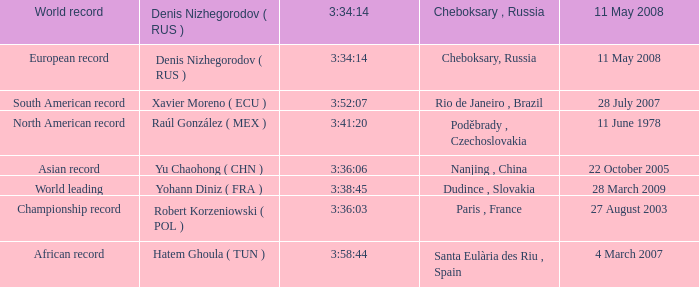When 3:41:20 is  3:34:14 what is cheboksary , russia? Poděbrady , Czechoslovakia. 